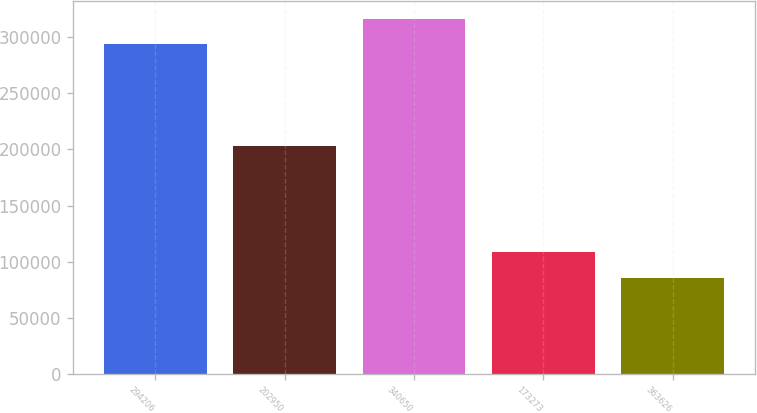Convert chart. <chart><loc_0><loc_0><loc_500><loc_500><bar_chart><fcel>294206<fcel>202950<fcel>340650<fcel>173273<fcel>363626<nl><fcel>294206<fcel>202950<fcel>316598<fcel>109023<fcel>85335<nl></chart> 